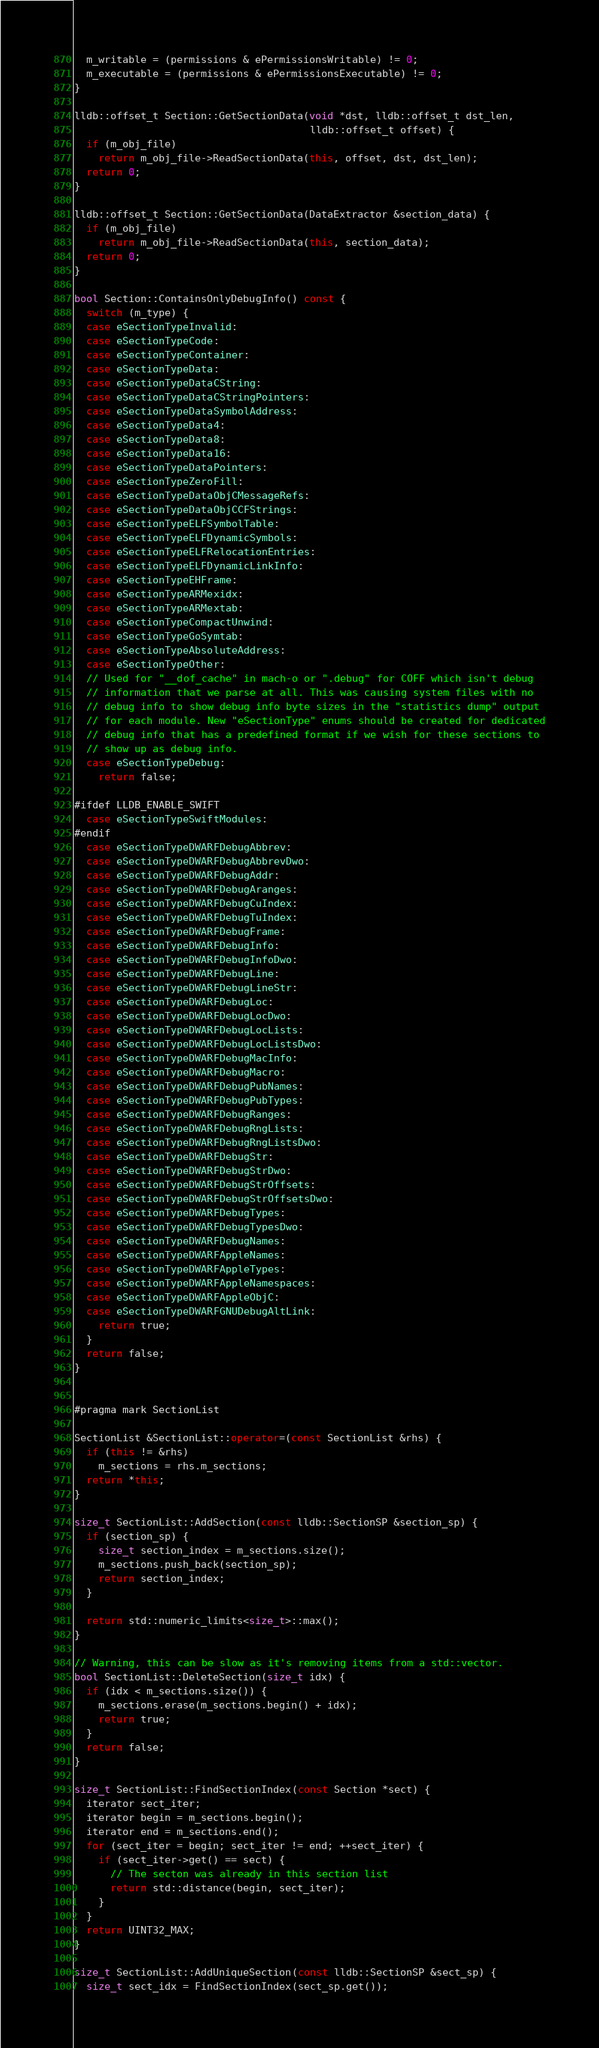Convert code to text. <code><loc_0><loc_0><loc_500><loc_500><_C++_>  m_writable = (permissions & ePermissionsWritable) != 0;
  m_executable = (permissions & ePermissionsExecutable) != 0;
}

lldb::offset_t Section::GetSectionData(void *dst, lldb::offset_t dst_len,
                                       lldb::offset_t offset) {
  if (m_obj_file)
    return m_obj_file->ReadSectionData(this, offset, dst, dst_len);
  return 0;
}

lldb::offset_t Section::GetSectionData(DataExtractor &section_data) {
  if (m_obj_file)
    return m_obj_file->ReadSectionData(this, section_data);
  return 0;
}

bool Section::ContainsOnlyDebugInfo() const {
  switch (m_type) {
  case eSectionTypeInvalid:
  case eSectionTypeCode:
  case eSectionTypeContainer:
  case eSectionTypeData:
  case eSectionTypeDataCString:
  case eSectionTypeDataCStringPointers:
  case eSectionTypeDataSymbolAddress:
  case eSectionTypeData4:
  case eSectionTypeData8:
  case eSectionTypeData16:
  case eSectionTypeDataPointers:
  case eSectionTypeZeroFill:
  case eSectionTypeDataObjCMessageRefs:
  case eSectionTypeDataObjCCFStrings:
  case eSectionTypeELFSymbolTable:
  case eSectionTypeELFDynamicSymbols:
  case eSectionTypeELFRelocationEntries:
  case eSectionTypeELFDynamicLinkInfo:
  case eSectionTypeEHFrame:
  case eSectionTypeARMexidx:
  case eSectionTypeARMextab:
  case eSectionTypeCompactUnwind:
  case eSectionTypeGoSymtab:
  case eSectionTypeAbsoluteAddress:
  case eSectionTypeOther:
  // Used for "__dof_cache" in mach-o or ".debug" for COFF which isn't debug
  // information that we parse at all. This was causing system files with no
  // debug info to show debug info byte sizes in the "statistics dump" output
  // for each module. New "eSectionType" enums should be created for dedicated
  // debug info that has a predefined format if we wish for these sections to
  // show up as debug info.
  case eSectionTypeDebug:
    return false;

#ifdef LLDB_ENABLE_SWIFT
  case eSectionTypeSwiftModules:
#endif
  case eSectionTypeDWARFDebugAbbrev:
  case eSectionTypeDWARFDebugAbbrevDwo:
  case eSectionTypeDWARFDebugAddr:
  case eSectionTypeDWARFDebugAranges:
  case eSectionTypeDWARFDebugCuIndex:
  case eSectionTypeDWARFDebugTuIndex:
  case eSectionTypeDWARFDebugFrame:
  case eSectionTypeDWARFDebugInfo:
  case eSectionTypeDWARFDebugInfoDwo:
  case eSectionTypeDWARFDebugLine:
  case eSectionTypeDWARFDebugLineStr:
  case eSectionTypeDWARFDebugLoc:
  case eSectionTypeDWARFDebugLocDwo:
  case eSectionTypeDWARFDebugLocLists:
  case eSectionTypeDWARFDebugLocListsDwo:
  case eSectionTypeDWARFDebugMacInfo:
  case eSectionTypeDWARFDebugMacro:
  case eSectionTypeDWARFDebugPubNames:
  case eSectionTypeDWARFDebugPubTypes:
  case eSectionTypeDWARFDebugRanges:
  case eSectionTypeDWARFDebugRngLists:
  case eSectionTypeDWARFDebugRngListsDwo:
  case eSectionTypeDWARFDebugStr:
  case eSectionTypeDWARFDebugStrDwo:
  case eSectionTypeDWARFDebugStrOffsets:
  case eSectionTypeDWARFDebugStrOffsetsDwo:
  case eSectionTypeDWARFDebugTypes:
  case eSectionTypeDWARFDebugTypesDwo:
  case eSectionTypeDWARFDebugNames:
  case eSectionTypeDWARFAppleNames:
  case eSectionTypeDWARFAppleTypes:
  case eSectionTypeDWARFAppleNamespaces:
  case eSectionTypeDWARFAppleObjC:
  case eSectionTypeDWARFGNUDebugAltLink:
    return true;
  }
  return false;
}


#pragma mark SectionList

SectionList &SectionList::operator=(const SectionList &rhs) {
  if (this != &rhs)
    m_sections = rhs.m_sections;
  return *this;
}

size_t SectionList::AddSection(const lldb::SectionSP &section_sp) {
  if (section_sp) {
    size_t section_index = m_sections.size();
    m_sections.push_back(section_sp);
    return section_index;
  }

  return std::numeric_limits<size_t>::max();
}

// Warning, this can be slow as it's removing items from a std::vector.
bool SectionList::DeleteSection(size_t idx) {
  if (idx < m_sections.size()) {
    m_sections.erase(m_sections.begin() + idx);
    return true;
  }
  return false;
}

size_t SectionList::FindSectionIndex(const Section *sect) {
  iterator sect_iter;
  iterator begin = m_sections.begin();
  iterator end = m_sections.end();
  for (sect_iter = begin; sect_iter != end; ++sect_iter) {
    if (sect_iter->get() == sect) {
      // The secton was already in this section list
      return std::distance(begin, sect_iter);
    }
  }
  return UINT32_MAX;
}

size_t SectionList::AddUniqueSection(const lldb::SectionSP &sect_sp) {
  size_t sect_idx = FindSectionIndex(sect_sp.get());</code> 